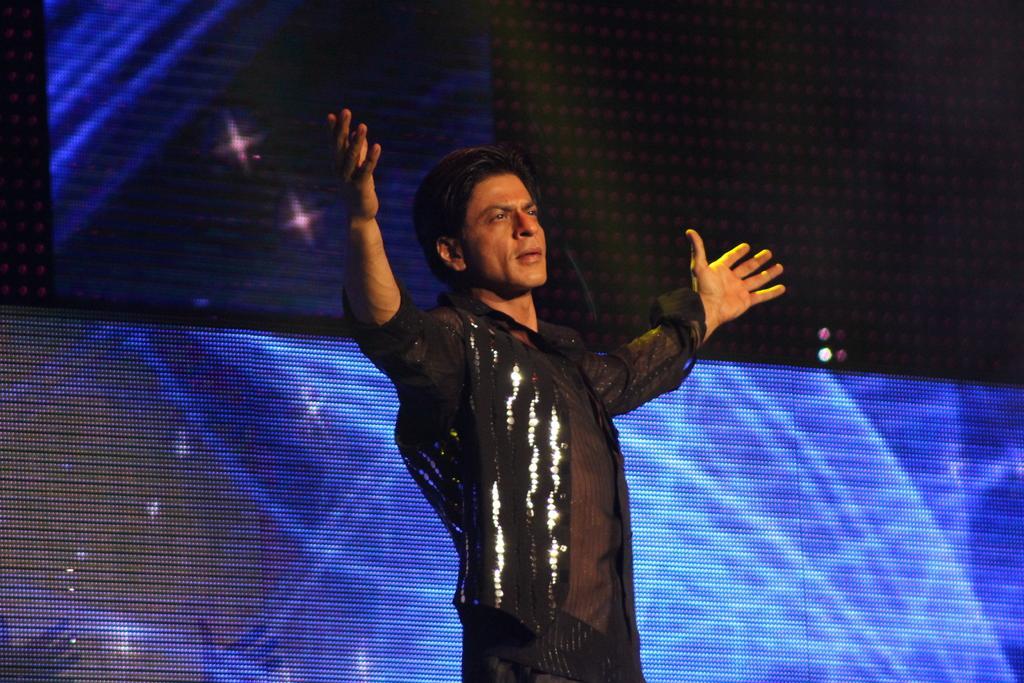Can you describe this image briefly? It is the picture of the Shahrukh khan,he is performing some action and behind the shahrukh khan there is an led screen. 